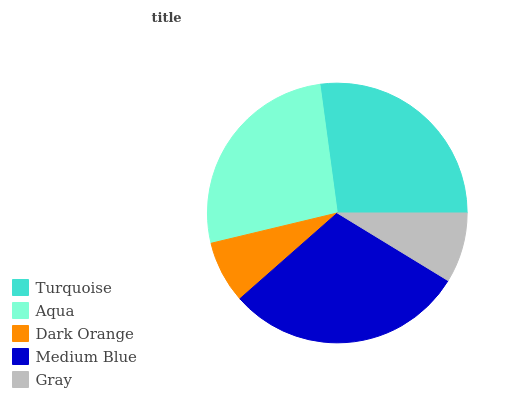Is Dark Orange the minimum?
Answer yes or no. Yes. Is Medium Blue the maximum?
Answer yes or no. Yes. Is Aqua the minimum?
Answer yes or no. No. Is Aqua the maximum?
Answer yes or no. No. Is Turquoise greater than Aqua?
Answer yes or no. Yes. Is Aqua less than Turquoise?
Answer yes or no. Yes. Is Aqua greater than Turquoise?
Answer yes or no. No. Is Turquoise less than Aqua?
Answer yes or no. No. Is Aqua the high median?
Answer yes or no. Yes. Is Aqua the low median?
Answer yes or no. Yes. Is Turquoise the high median?
Answer yes or no. No. Is Turquoise the low median?
Answer yes or no. No. 